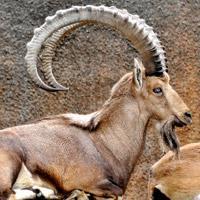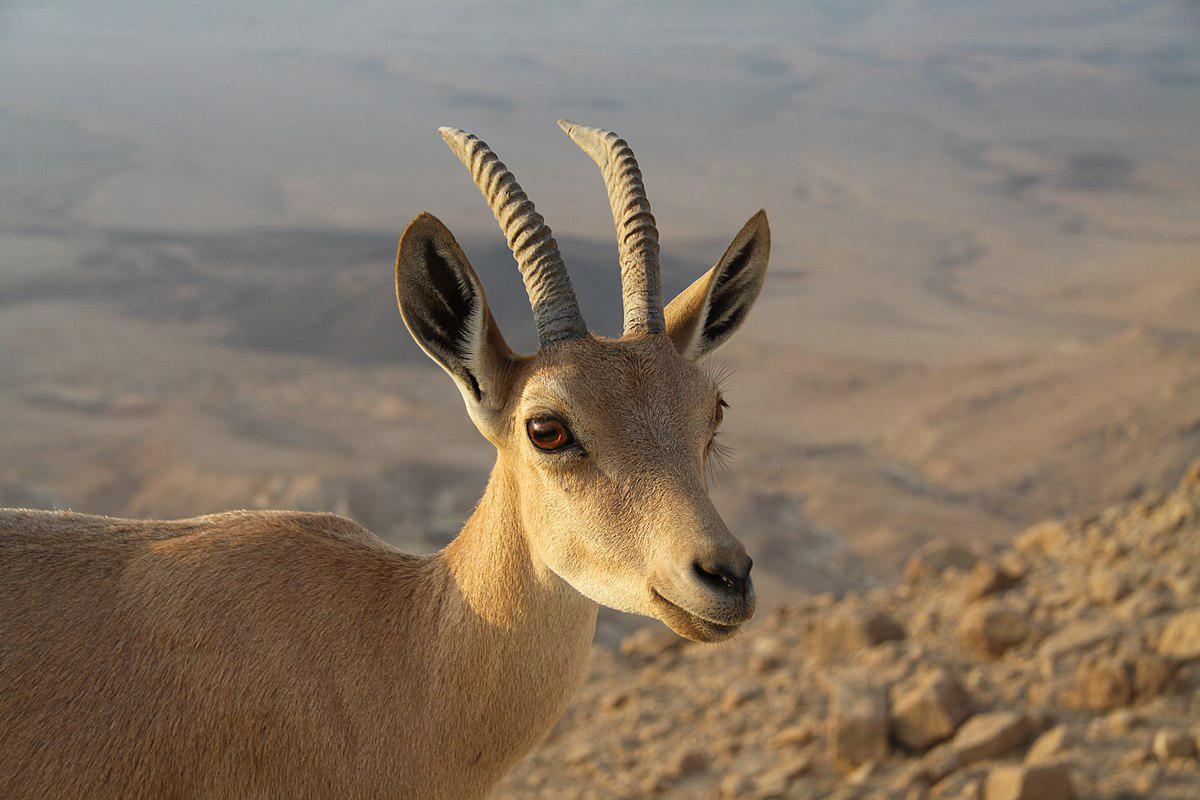The first image is the image on the left, the second image is the image on the right. Analyze the images presented: Is the assertion "One animal is laying down." valid? Answer yes or no. Yes. 